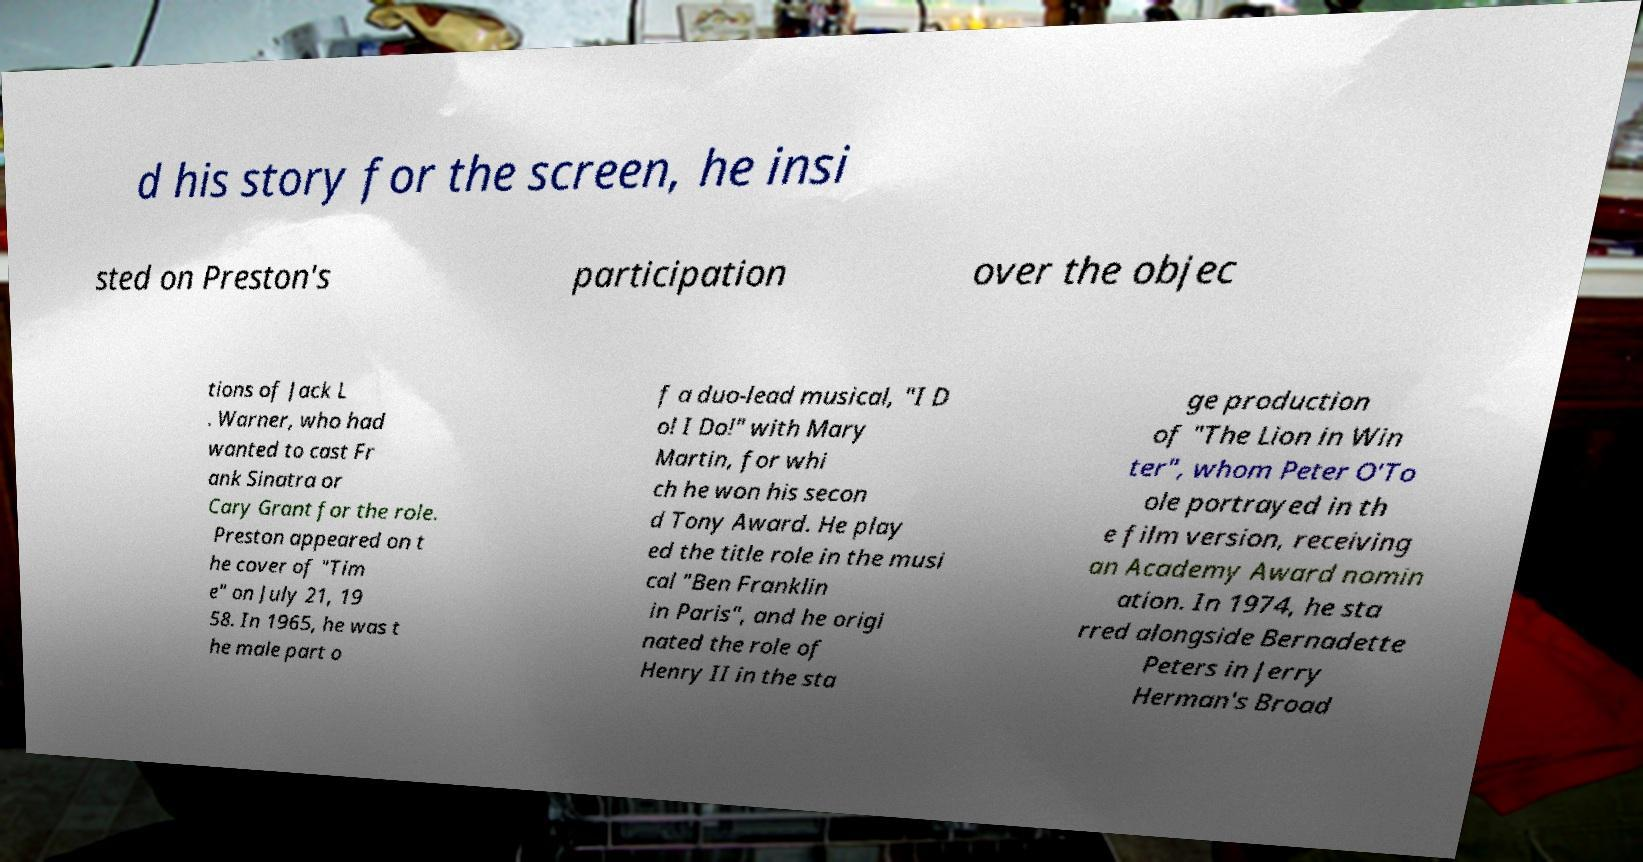Could you assist in decoding the text presented in this image and type it out clearly? d his story for the screen, he insi sted on Preston's participation over the objec tions of Jack L . Warner, who had wanted to cast Fr ank Sinatra or Cary Grant for the role. Preston appeared on t he cover of "Tim e" on July 21, 19 58. In 1965, he was t he male part o f a duo-lead musical, "I D o! I Do!" with Mary Martin, for whi ch he won his secon d Tony Award. He play ed the title role in the musi cal "Ben Franklin in Paris", and he origi nated the role of Henry II in the sta ge production of "The Lion in Win ter", whom Peter O'To ole portrayed in th e film version, receiving an Academy Award nomin ation. In 1974, he sta rred alongside Bernadette Peters in Jerry Herman's Broad 